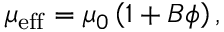Convert formula to latex. <formula><loc_0><loc_0><loc_500><loc_500>\mu _ { e f f } = \mu _ { 0 } \left ( 1 + B \phi \right ) ,</formula> 